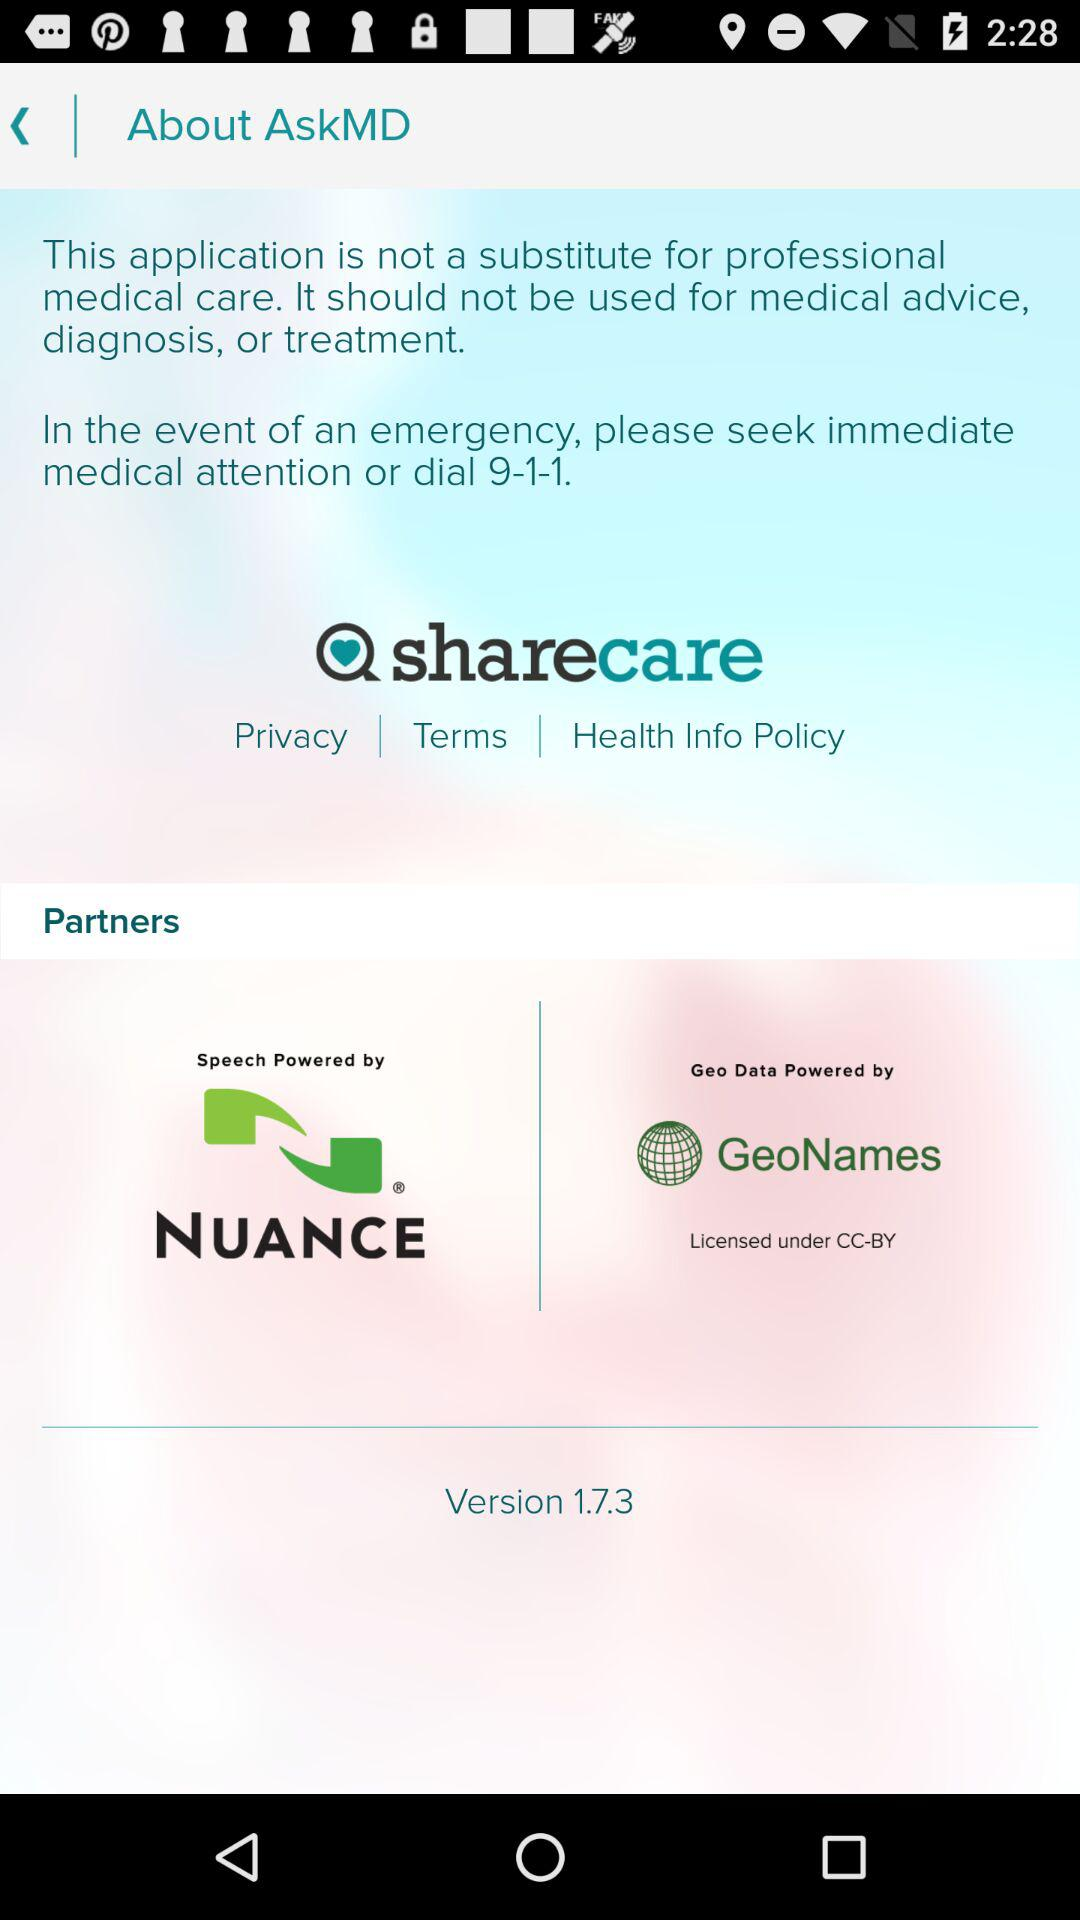What is the version? The version is 1.7.3. 